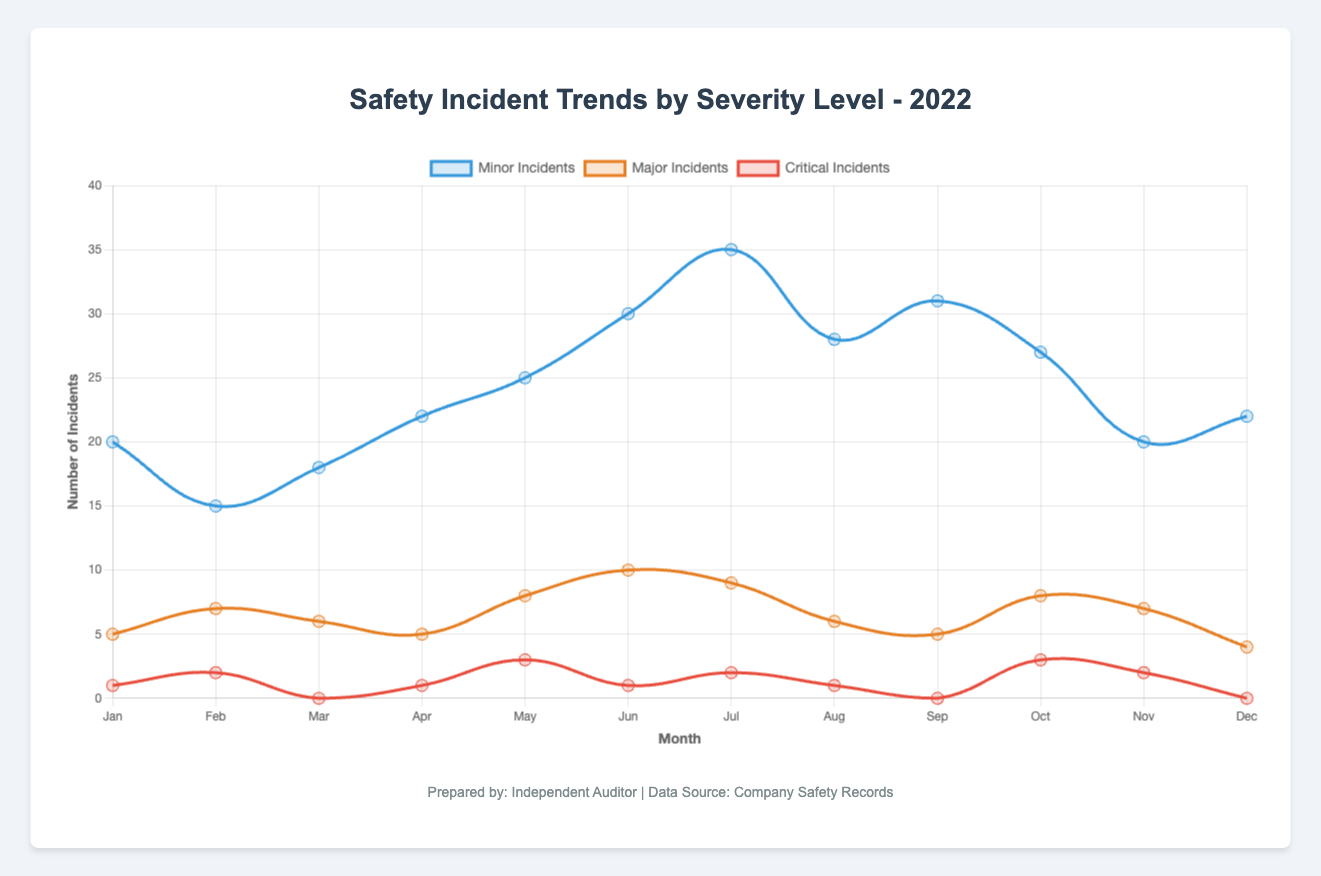Which month had the highest number of minor incidents in 2022? To identify the month with the highest number of minor incidents, we look for the month with the tallest blue line representing minor incidents. July had the highest point on the blue line with 35 incidents.
Answer: July How many more minor incidents occurred in June compared to February? We need to subtract the number of minor incidents in February from those in June. June had 30 minor incidents, and February had 15. So, 30 - 15 = 15 more incidents in June.
Answer: 15 Which severity level had the highest overall number of incidents in December? We compare the three lines (blue for minor, orange for major, and red for critical) in December. The blue line representing minor incidents is highest with 22 incidents.
Answer: Minor What is the average number of major incidents per month for the year 2022? To find the average, we sum all the major incidents and divide by 12. The sum is 5+7+6+5+8+10+9+6+5+8+7+4 = 80. The average is 80/12 ≈ 6.67.
Answer: 6.67 Which two months had the same number of critical incidents? By observing the red line representing critical incidents, we see that both March and September had 0 critical incidents.
Answer: March and September What is the difference in the total number of minor and major incidents for the entire year? Sum up the total incidents for each severity level, then subtract the totals: Minor: 20+15+18+22+25+30+35+28+31+27+20+22 = 293. Major: 5+7+6+5+8+10+9+6+5+8+7+4 = 80. Difference: 293 - 80 = 213.
Answer: 213 How did the trend of minor incidents change from May to June? Observing the blue line, we see a steady increase from May to June. The incidents rose from 25 in May to 30 in June.
Answer: Increased Which month experienced no major incidents? We locate the month where the orange line (representing major incidents) hits zero. No such point appears in the graph, indicating major incidents occurred every month.
Answer: None 